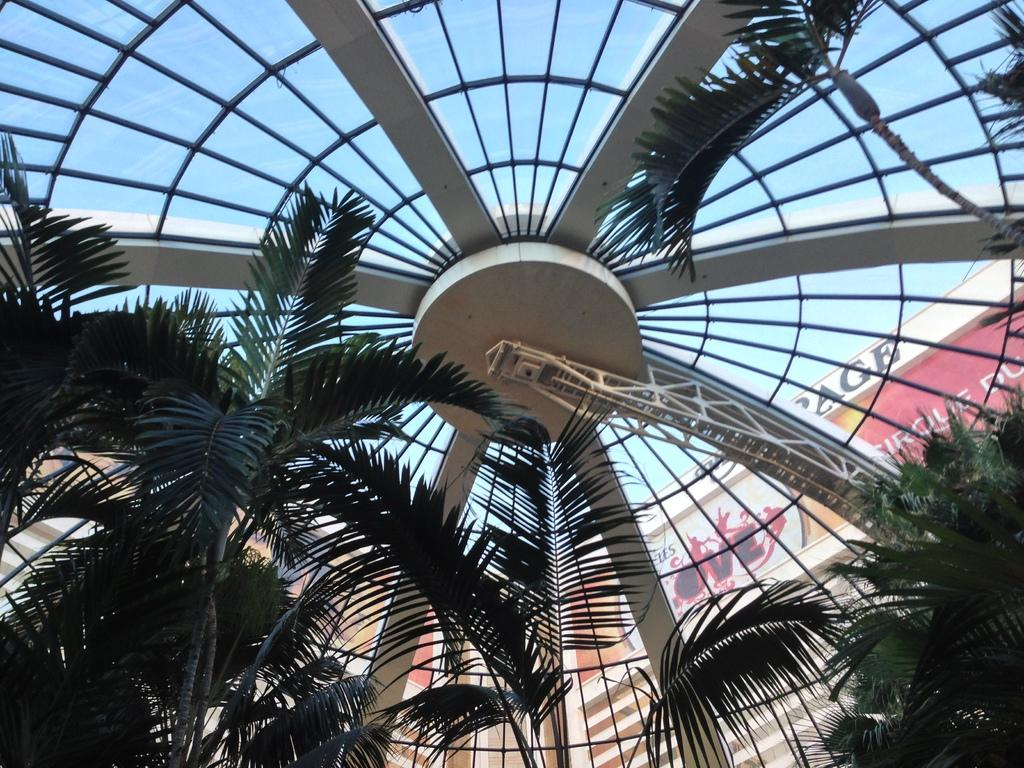What type of structures can be seen in the image? There are buildings in the image. What type of vegetation is present in the image? There are trees in the image. What is the average income of the people living in the buildings in the image? There is no information provided about the income of the people living in the buildings, so it cannot be determined from the image. Can you see any fangs on the trees in the image? Trees do not have fangs, so this question is not applicable to the image. 